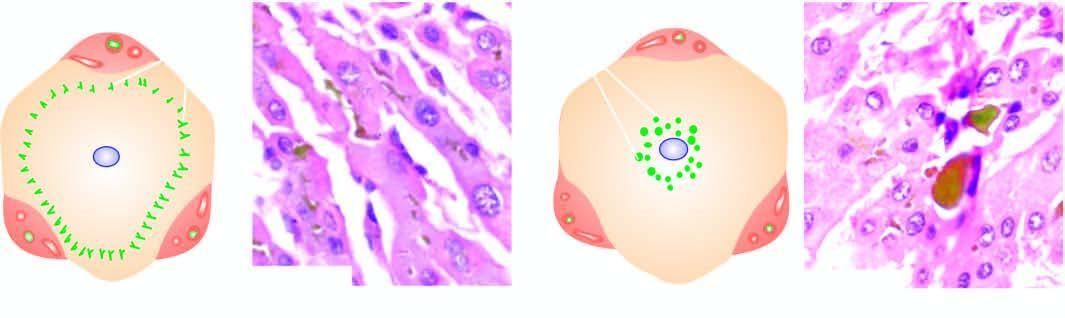what does extrahepatic cholestasis show?
Answer the question using a single word or phrase. Characteristic bile lakes due to rupture of canaliculi in the hepatocytes in the centrilobular area 